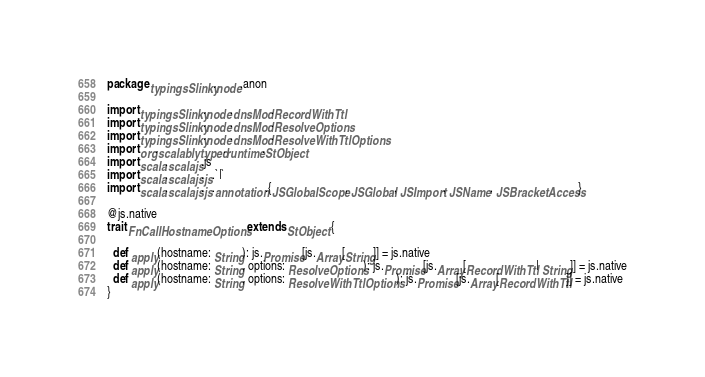<code> <loc_0><loc_0><loc_500><loc_500><_Scala_>package typingsSlinky.node.anon

import typingsSlinky.node.dnsMod.RecordWithTtl
import typingsSlinky.node.dnsMod.ResolveOptions
import typingsSlinky.node.dnsMod.ResolveWithTtlOptions
import org.scalablytyped.runtime.StObject
import scala.scalajs.js
import scala.scalajs.js.`|`
import scala.scalajs.js.annotation.{JSGlobalScope, JSGlobal, JSImport, JSName, JSBracketAccess}

@js.native
trait FnCallHostnameOptions extends StObject {
  
  def apply(hostname: String): js.Promise[js.Array[String]] = js.native
  def apply(hostname: String, options: ResolveOptions): js.Promise[js.Array[RecordWithTtl | String]] = js.native
  def apply(hostname: String, options: ResolveWithTtlOptions): js.Promise[js.Array[RecordWithTtl]] = js.native
}
</code> 